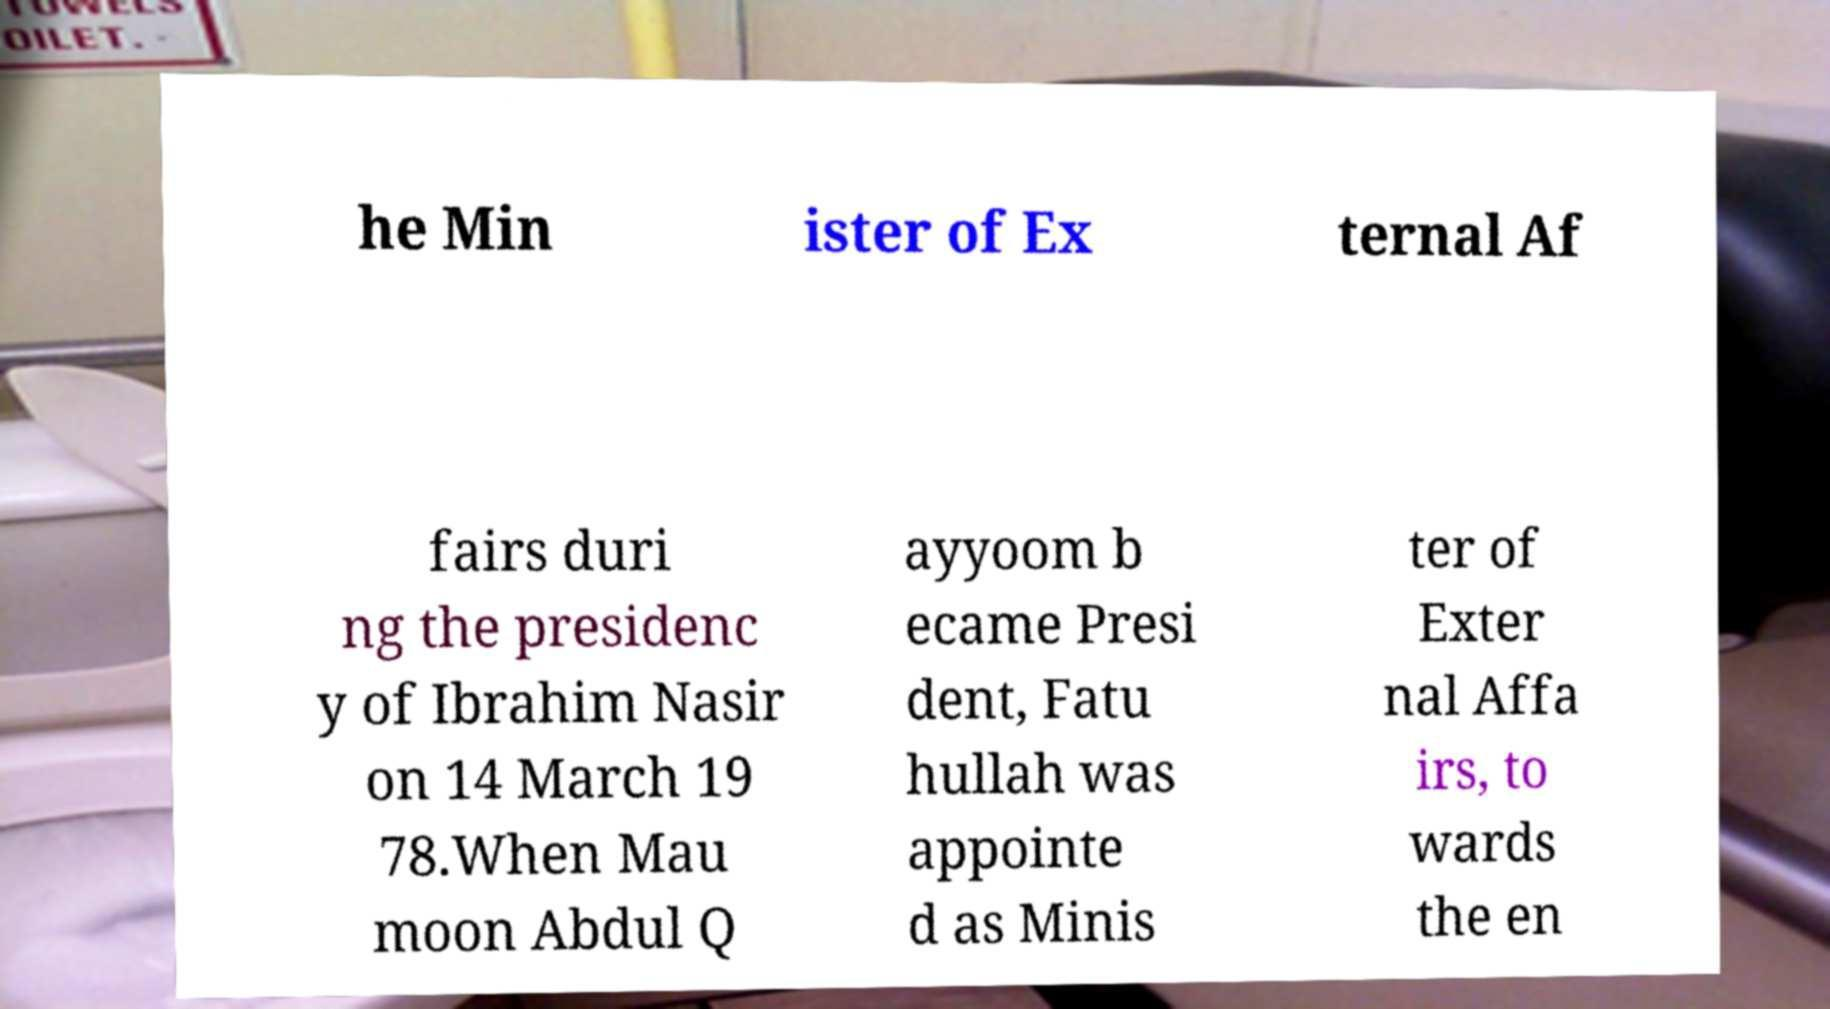For documentation purposes, I need the text within this image transcribed. Could you provide that? he Min ister of Ex ternal Af fairs duri ng the presidenc y of Ibrahim Nasir on 14 March 19 78.When Mau moon Abdul Q ayyoom b ecame Presi dent, Fatu hullah was appointe d as Minis ter of Exter nal Affa irs, to wards the en 